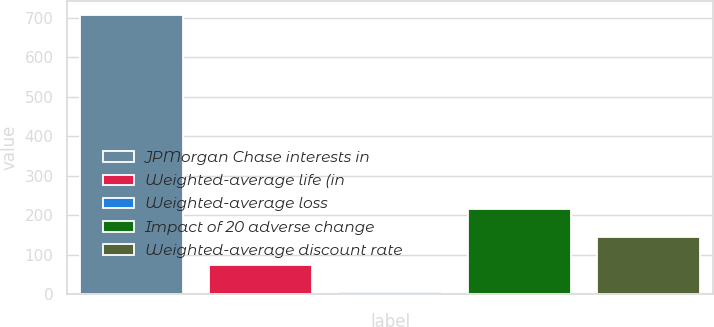Convert chart. <chart><loc_0><loc_0><loc_500><loc_500><bar_chart><fcel>JPMorgan Chase interests in<fcel>Weighted-average life (in<fcel>Weighted-average loss<fcel>Impact of 20 adverse change<fcel>Weighted-average discount rate<nl><fcel>708<fcel>75.48<fcel>5.2<fcel>216.04<fcel>145.76<nl></chart> 